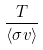<formula> <loc_0><loc_0><loc_500><loc_500>\frac { T } { \langle \sigma v \rangle }</formula> 